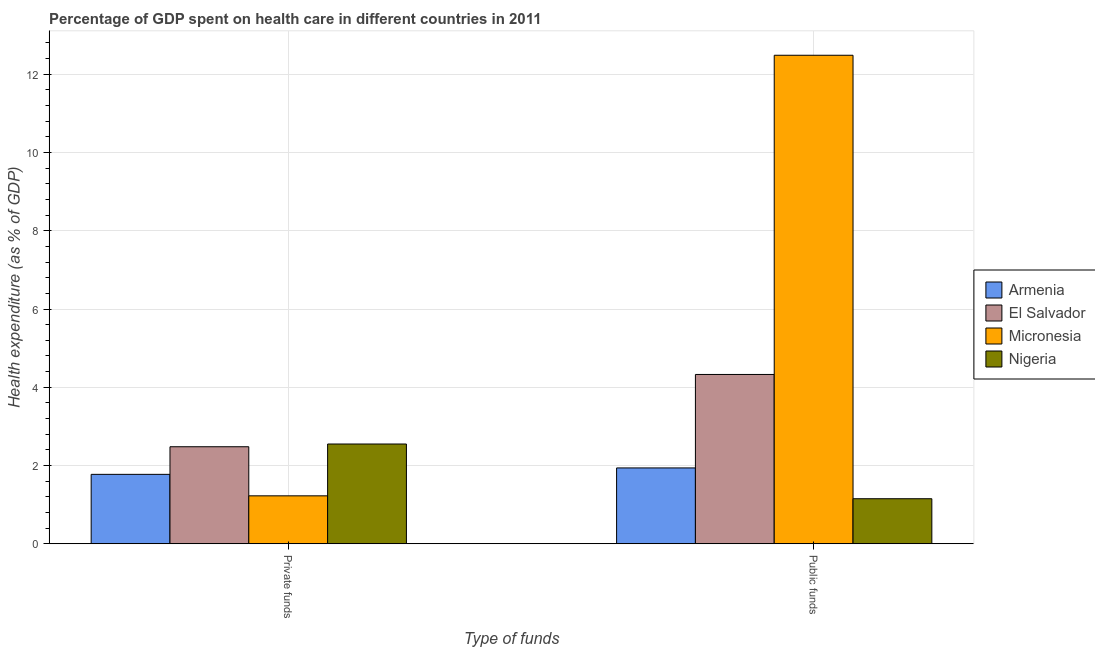How many groups of bars are there?
Offer a terse response. 2. Are the number of bars on each tick of the X-axis equal?
Your response must be concise. Yes. What is the label of the 2nd group of bars from the left?
Your answer should be compact. Public funds. What is the amount of public funds spent in healthcare in Micronesia?
Give a very brief answer. 12.49. Across all countries, what is the maximum amount of public funds spent in healthcare?
Keep it short and to the point. 12.49. Across all countries, what is the minimum amount of public funds spent in healthcare?
Provide a short and direct response. 1.15. In which country was the amount of private funds spent in healthcare maximum?
Give a very brief answer. Nigeria. In which country was the amount of private funds spent in healthcare minimum?
Your answer should be compact. Micronesia. What is the total amount of public funds spent in healthcare in the graph?
Make the answer very short. 19.9. What is the difference between the amount of private funds spent in healthcare in El Salvador and that in Nigeria?
Give a very brief answer. -0.07. What is the difference between the amount of private funds spent in healthcare in Armenia and the amount of public funds spent in healthcare in Nigeria?
Your answer should be very brief. 0.62. What is the average amount of private funds spent in healthcare per country?
Offer a very short reply. 2.01. What is the difference between the amount of public funds spent in healthcare and amount of private funds spent in healthcare in Nigeria?
Your answer should be very brief. -1.4. What is the ratio of the amount of private funds spent in healthcare in Micronesia to that in Nigeria?
Make the answer very short. 0.48. In how many countries, is the amount of public funds spent in healthcare greater than the average amount of public funds spent in healthcare taken over all countries?
Ensure brevity in your answer.  1. What does the 1st bar from the left in Public funds represents?
Offer a terse response. Armenia. What does the 3rd bar from the right in Private funds represents?
Ensure brevity in your answer.  El Salvador. Are all the bars in the graph horizontal?
Make the answer very short. No. How many countries are there in the graph?
Give a very brief answer. 4. Are the values on the major ticks of Y-axis written in scientific E-notation?
Ensure brevity in your answer.  No. Does the graph contain grids?
Provide a succinct answer. Yes. What is the title of the graph?
Provide a short and direct response. Percentage of GDP spent on health care in different countries in 2011. Does "Brazil" appear as one of the legend labels in the graph?
Your answer should be very brief. No. What is the label or title of the X-axis?
Provide a short and direct response. Type of funds. What is the label or title of the Y-axis?
Your answer should be compact. Health expenditure (as % of GDP). What is the Health expenditure (as % of GDP) in Armenia in Private funds?
Offer a terse response. 1.77. What is the Health expenditure (as % of GDP) of El Salvador in Private funds?
Make the answer very short. 2.48. What is the Health expenditure (as % of GDP) in Micronesia in Private funds?
Offer a terse response. 1.23. What is the Health expenditure (as % of GDP) in Nigeria in Private funds?
Make the answer very short. 2.55. What is the Health expenditure (as % of GDP) in Armenia in Public funds?
Keep it short and to the point. 1.94. What is the Health expenditure (as % of GDP) of El Salvador in Public funds?
Keep it short and to the point. 4.33. What is the Health expenditure (as % of GDP) in Micronesia in Public funds?
Give a very brief answer. 12.49. What is the Health expenditure (as % of GDP) of Nigeria in Public funds?
Offer a terse response. 1.15. Across all Type of funds, what is the maximum Health expenditure (as % of GDP) in Armenia?
Your response must be concise. 1.94. Across all Type of funds, what is the maximum Health expenditure (as % of GDP) in El Salvador?
Give a very brief answer. 4.33. Across all Type of funds, what is the maximum Health expenditure (as % of GDP) of Micronesia?
Your response must be concise. 12.49. Across all Type of funds, what is the maximum Health expenditure (as % of GDP) of Nigeria?
Provide a short and direct response. 2.55. Across all Type of funds, what is the minimum Health expenditure (as % of GDP) of Armenia?
Give a very brief answer. 1.77. Across all Type of funds, what is the minimum Health expenditure (as % of GDP) in El Salvador?
Provide a succinct answer. 2.48. Across all Type of funds, what is the minimum Health expenditure (as % of GDP) of Micronesia?
Provide a short and direct response. 1.23. Across all Type of funds, what is the minimum Health expenditure (as % of GDP) in Nigeria?
Your answer should be very brief. 1.15. What is the total Health expenditure (as % of GDP) in Armenia in the graph?
Offer a very short reply. 3.71. What is the total Health expenditure (as % of GDP) in El Salvador in the graph?
Provide a succinct answer. 6.81. What is the total Health expenditure (as % of GDP) in Micronesia in the graph?
Offer a very short reply. 13.71. What is the total Health expenditure (as % of GDP) of Nigeria in the graph?
Ensure brevity in your answer.  3.7. What is the difference between the Health expenditure (as % of GDP) of Armenia in Private funds and that in Public funds?
Your response must be concise. -0.16. What is the difference between the Health expenditure (as % of GDP) in El Salvador in Private funds and that in Public funds?
Your answer should be very brief. -1.85. What is the difference between the Health expenditure (as % of GDP) of Micronesia in Private funds and that in Public funds?
Provide a succinct answer. -11.26. What is the difference between the Health expenditure (as % of GDP) of Nigeria in Private funds and that in Public funds?
Your answer should be compact. 1.4. What is the difference between the Health expenditure (as % of GDP) of Armenia in Private funds and the Health expenditure (as % of GDP) of El Salvador in Public funds?
Your answer should be compact. -2.55. What is the difference between the Health expenditure (as % of GDP) of Armenia in Private funds and the Health expenditure (as % of GDP) of Micronesia in Public funds?
Offer a terse response. -10.71. What is the difference between the Health expenditure (as % of GDP) of Armenia in Private funds and the Health expenditure (as % of GDP) of Nigeria in Public funds?
Offer a very short reply. 0.62. What is the difference between the Health expenditure (as % of GDP) in El Salvador in Private funds and the Health expenditure (as % of GDP) in Micronesia in Public funds?
Your answer should be compact. -10.01. What is the difference between the Health expenditure (as % of GDP) in El Salvador in Private funds and the Health expenditure (as % of GDP) in Nigeria in Public funds?
Ensure brevity in your answer.  1.33. What is the difference between the Health expenditure (as % of GDP) of Micronesia in Private funds and the Health expenditure (as % of GDP) of Nigeria in Public funds?
Your answer should be very brief. 0.07. What is the average Health expenditure (as % of GDP) of Armenia per Type of funds?
Your answer should be compact. 1.86. What is the average Health expenditure (as % of GDP) of El Salvador per Type of funds?
Make the answer very short. 3.4. What is the average Health expenditure (as % of GDP) of Micronesia per Type of funds?
Your answer should be compact. 6.86. What is the average Health expenditure (as % of GDP) in Nigeria per Type of funds?
Your answer should be compact. 1.85. What is the difference between the Health expenditure (as % of GDP) of Armenia and Health expenditure (as % of GDP) of El Salvador in Private funds?
Your answer should be compact. -0.71. What is the difference between the Health expenditure (as % of GDP) in Armenia and Health expenditure (as % of GDP) in Micronesia in Private funds?
Provide a short and direct response. 0.55. What is the difference between the Health expenditure (as % of GDP) of Armenia and Health expenditure (as % of GDP) of Nigeria in Private funds?
Provide a short and direct response. -0.78. What is the difference between the Health expenditure (as % of GDP) in El Salvador and Health expenditure (as % of GDP) in Micronesia in Private funds?
Provide a succinct answer. 1.25. What is the difference between the Health expenditure (as % of GDP) in El Salvador and Health expenditure (as % of GDP) in Nigeria in Private funds?
Provide a short and direct response. -0.07. What is the difference between the Health expenditure (as % of GDP) in Micronesia and Health expenditure (as % of GDP) in Nigeria in Private funds?
Your answer should be very brief. -1.32. What is the difference between the Health expenditure (as % of GDP) of Armenia and Health expenditure (as % of GDP) of El Salvador in Public funds?
Provide a succinct answer. -2.39. What is the difference between the Health expenditure (as % of GDP) in Armenia and Health expenditure (as % of GDP) in Micronesia in Public funds?
Offer a very short reply. -10.55. What is the difference between the Health expenditure (as % of GDP) of Armenia and Health expenditure (as % of GDP) of Nigeria in Public funds?
Your answer should be compact. 0.79. What is the difference between the Health expenditure (as % of GDP) of El Salvador and Health expenditure (as % of GDP) of Micronesia in Public funds?
Your answer should be very brief. -8.16. What is the difference between the Health expenditure (as % of GDP) of El Salvador and Health expenditure (as % of GDP) of Nigeria in Public funds?
Give a very brief answer. 3.18. What is the difference between the Health expenditure (as % of GDP) in Micronesia and Health expenditure (as % of GDP) in Nigeria in Public funds?
Provide a short and direct response. 11.33. What is the ratio of the Health expenditure (as % of GDP) in Armenia in Private funds to that in Public funds?
Give a very brief answer. 0.92. What is the ratio of the Health expenditure (as % of GDP) in El Salvador in Private funds to that in Public funds?
Offer a very short reply. 0.57. What is the ratio of the Health expenditure (as % of GDP) in Micronesia in Private funds to that in Public funds?
Give a very brief answer. 0.1. What is the ratio of the Health expenditure (as % of GDP) in Nigeria in Private funds to that in Public funds?
Provide a short and direct response. 2.21. What is the difference between the highest and the second highest Health expenditure (as % of GDP) of Armenia?
Offer a very short reply. 0.16. What is the difference between the highest and the second highest Health expenditure (as % of GDP) of El Salvador?
Your answer should be compact. 1.85. What is the difference between the highest and the second highest Health expenditure (as % of GDP) in Micronesia?
Your response must be concise. 11.26. What is the difference between the highest and the second highest Health expenditure (as % of GDP) of Nigeria?
Offer a terse response. 1.4. What is the difference between the highest and the lowest Health expenditure (as % of GDP) in Armenia?
Offer a very short reply. 0.16. What is the difference between the highest and the lowest Health expenditure (as % of GDP) in El Salvador?
Ensure brevity in your answer.  1.85. What is the difference between the highest and the lowest Health expenditure (as % of GDP) in Micronesia?
Offer a terse response. 11.26. What is the difference between the highest and the lowest Health expenditure (as % of GDP) in Nigeria?
Keep it short and to the point. 1.4. 